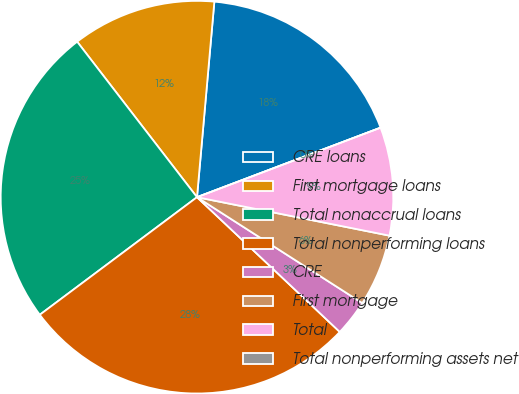Convert chart. <chart><loc_0><loc_0><loc_500><loc_500><pie_chart><fcel>CRE loans<fcel>First mortgage loans<fcel>Total nonaccrual loans<fcel>Total nonperforming loans<fcel>CRE<fcel>First mortgage<fcel>Total<fcel>Total nonperforming assets net<nl><fcel>17.83%<fcel>11.86%<fcel>24.77%<fcel>27.74%<fcel>2.97%<fcel>5.93%<fcel>8.9%<fcel>0.0%<nl></chart> 